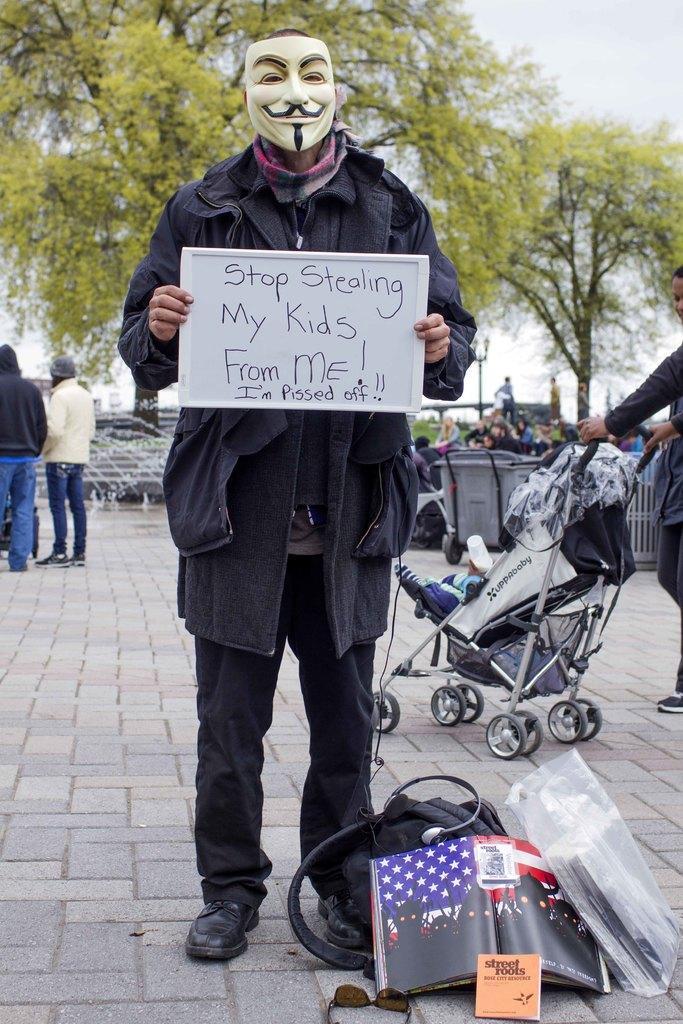Can you describe this image briefly? In this image there is a person standing wearing a mask and holding a poster in his hands, on that poster there is some text, on the ground there are bags and glasses, in the background there are people standing and there is a woman holding a baby stroller and there are trees. 